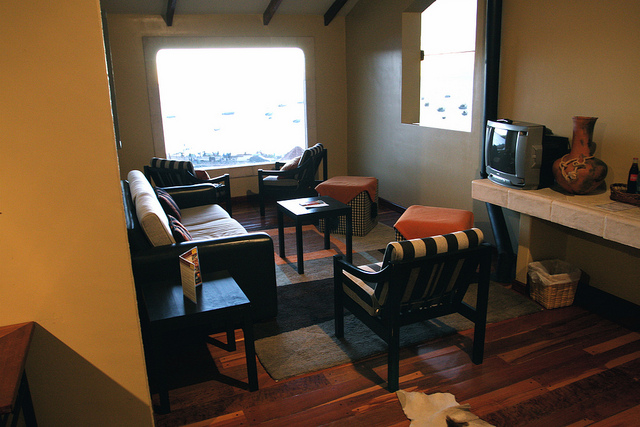<image>What electronic device is in this room? There is no electronic device in the image. However, it can be a television or TV. What electronic device is in this room? I don't know what electronic device is in this room. It can be seen both television and tv. 